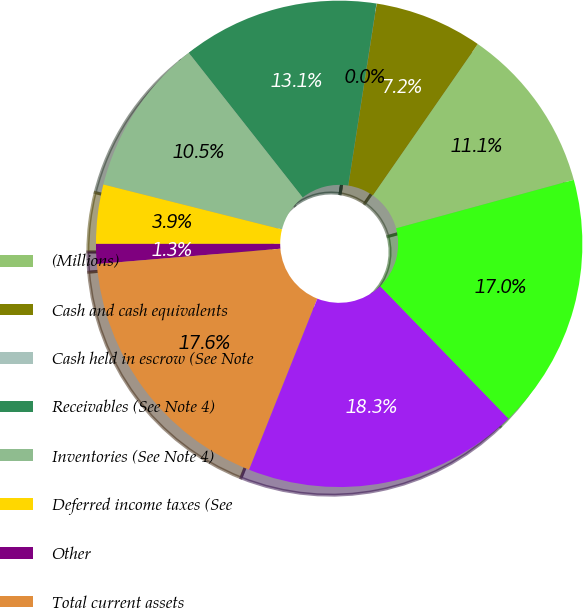Convert chart to OTSL. <chart><loc_0><loc_0><loc_500><loc_500><pie_chart><fcel>(Millions)<fcel>Cash and cash equivalents<fcel>Cash held in escrow (See Note<fcel>Receivables (See Note 4)<fcel>Inventories (See Note 4)<fcel>Deferred income taxes (See<fcel>Other<fcel>Total current assets<fcel>Property (See Note 5)<fcel>Less accumulated depreciation<nl><fcel>11.11%<fcel>7.19%<fcel>0.01%<fcel>13.07%<fcel>10.46%<fcel>3.93%<fcel>1.32%<fcel>17.64%<fcel>18.29%<fcel>16.99%<nl></chart> 